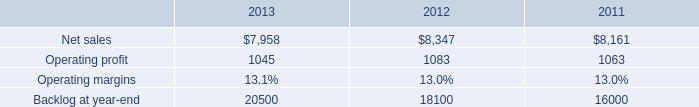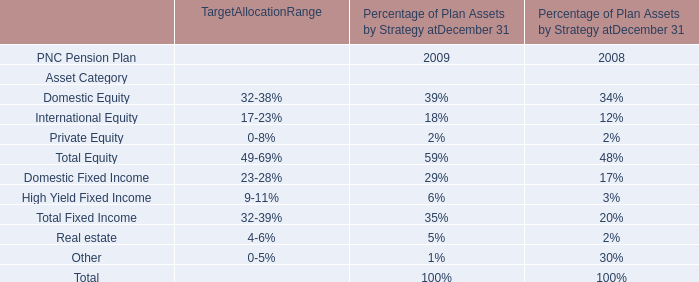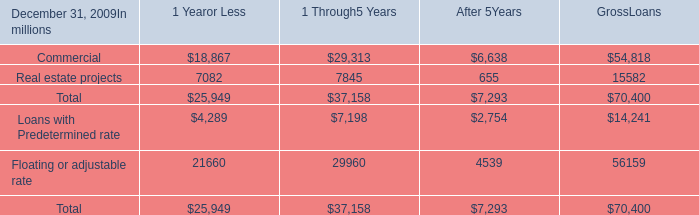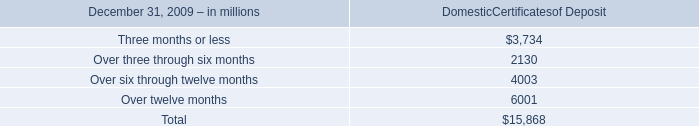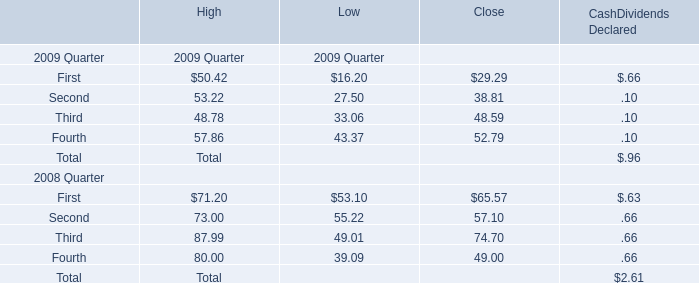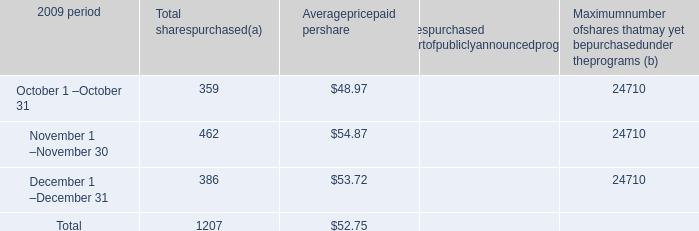What was the total amount of Domestic Certificates of Deposit excluding those Domestic Certificates of Deposit greater than 5000 in 2009? (in million) 
Computations: ((3734 + 2130) + 4003)
Answer: 9867.0. 